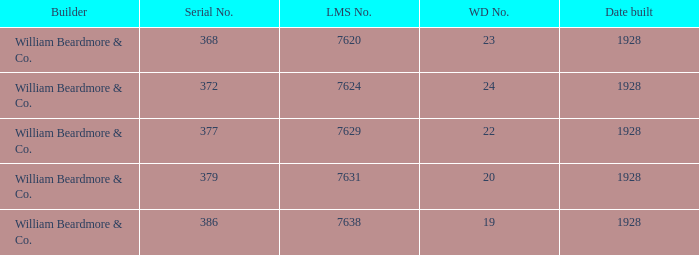Name the builder for serial number being 377 William Beardmore & Co. 